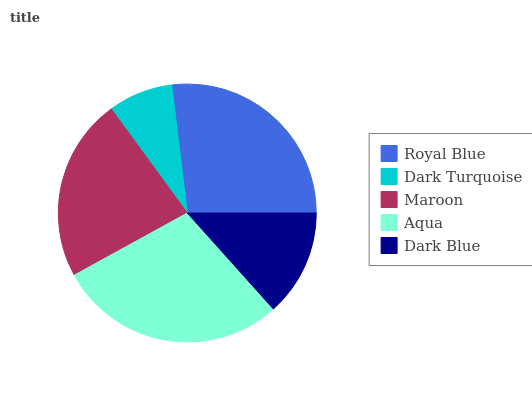Is Dark Turquoise the minimum?
Answer yes or no. Yes. Is Aqua the maximum?
Answer yes or no. Yes. Is Maroon the minimum?
Answer yes or no. No. Is Maroon the maximum?
Answer yes or no. No. Is Maroon greater than Dark Turquoise?
Answer yes or no. Yes. Is Dark Turquoise less than Maroon?
Answer yes or no. Yes. Is Dark Turquoise greater than Maroon?
Answer yes or no. No. Is Maroon less than Dark Turquoise?
Answer yes or no. No. Is Maroon the high median?
Answer yes or no. Yes. Is Maroon the low median?
Answer yes or no. Yes. Is Royal Blue the high median?
Answer yes or no. No. Is Dark Turquoise the low median?
Answer yes or no. No. 